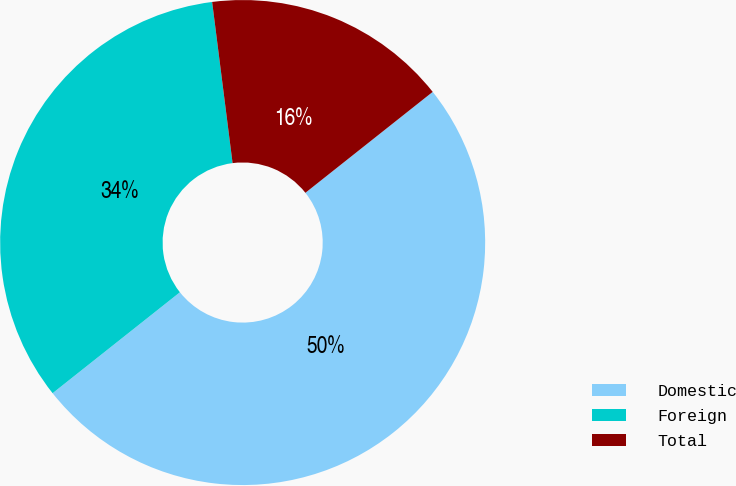<chart> <loc_0><loc_0><loc_500><loc_500><pie_chart><fcel>Domestic<fcel>Foreign<fcel>Total<nl><fcel>50.0%<fcel>33.66%<fcel>16.34%<nl></chart> 